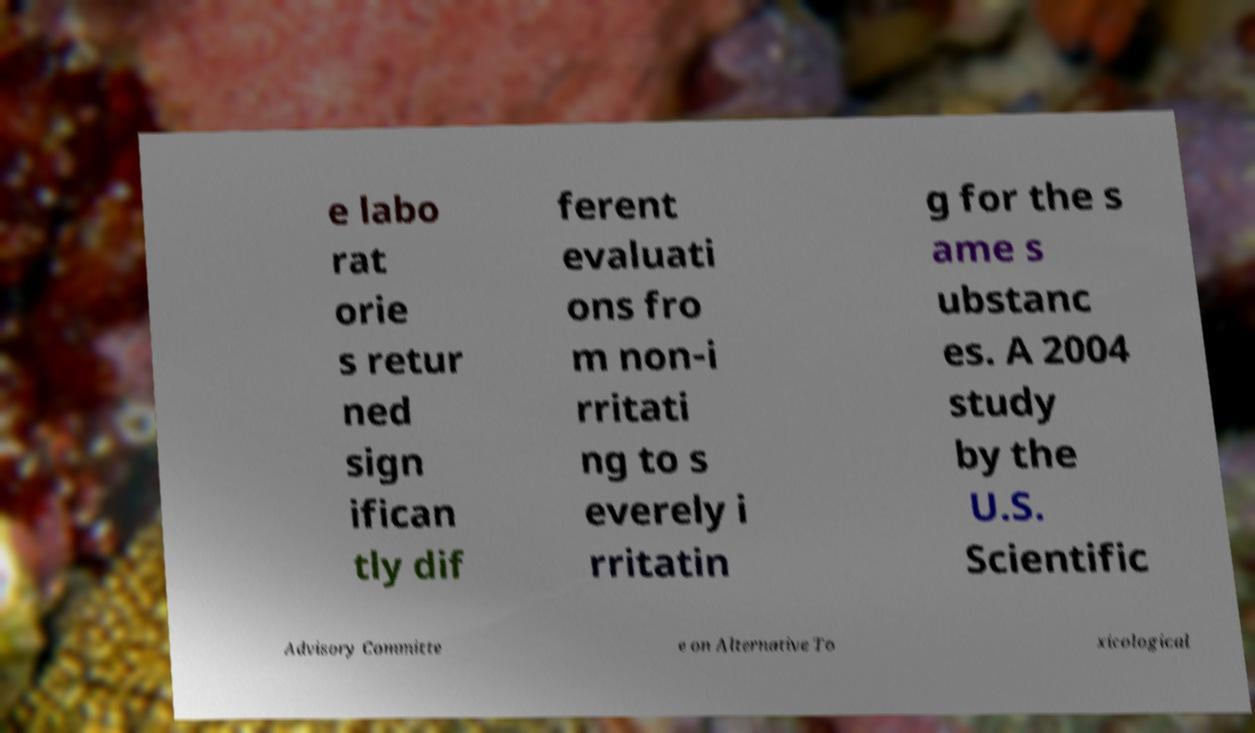Can you accurately transcribe the text from the provided image for me? e labo rat orie s retur ned sign ifican tly dif ferent evaluati ons fro m non-i rritati ng to s everely i rritatin g for the s ame s ubstanc es. A 2004 study by the U.S. Scientific Advisory Committe e on Alternative To xicological 